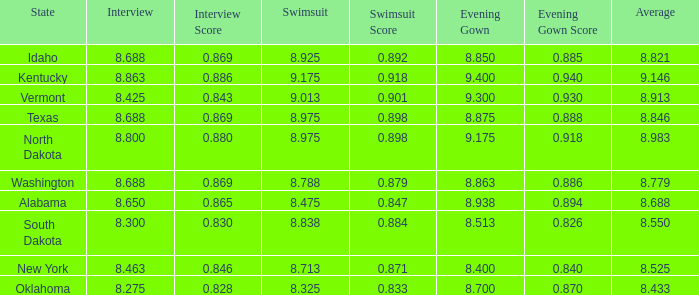What is the highest average of the contestant from Texas with an evening gown larger than 8.875? None. 